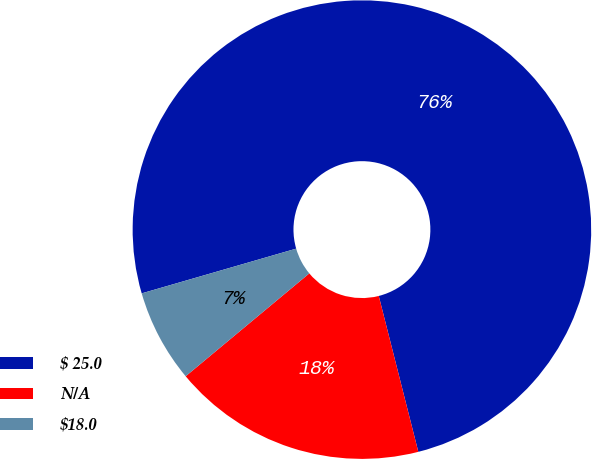Convert chart. <chart><loc_0><loc_0><loc_500><loc_500><pie_chart><fcel>$ 25.0<fcel>N/A<fcel>$18.0<nl><fcel>75.53%<fcel>17.91%<fcel>6.56%<nl></chart> 